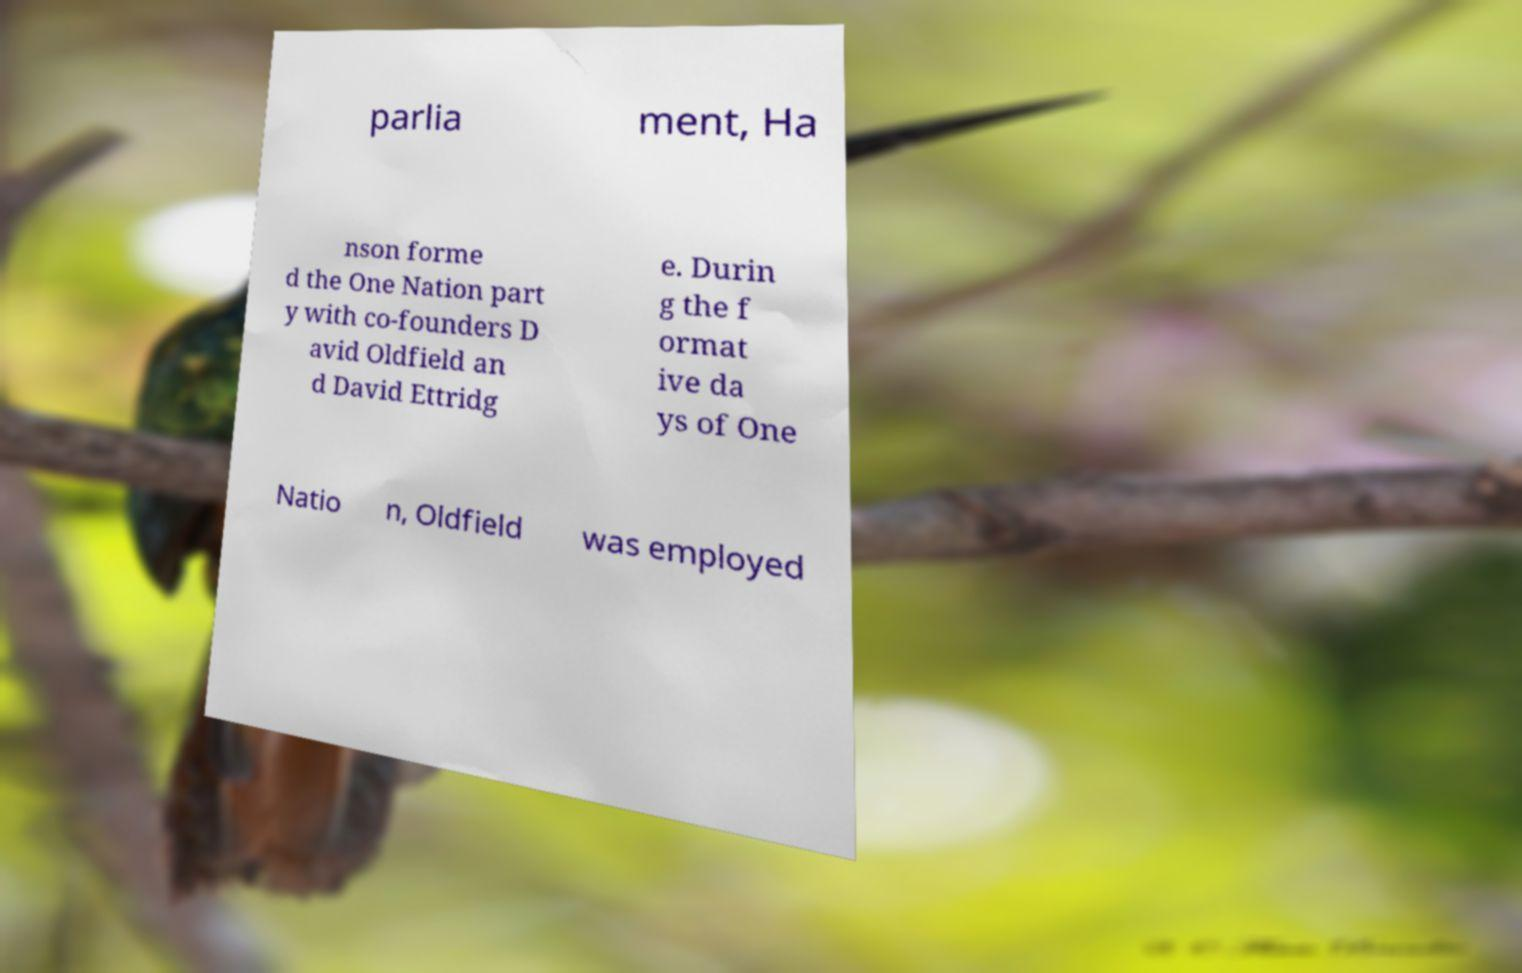Please read and relay the text visible in this image. What does it say? parlia ment, Ha nson forme d the One Nation part y with co-founders D avid Oldfield an d David Ettridg e. Durin g the f ormat ive da ys of One Natio n, Oldfield was employed 